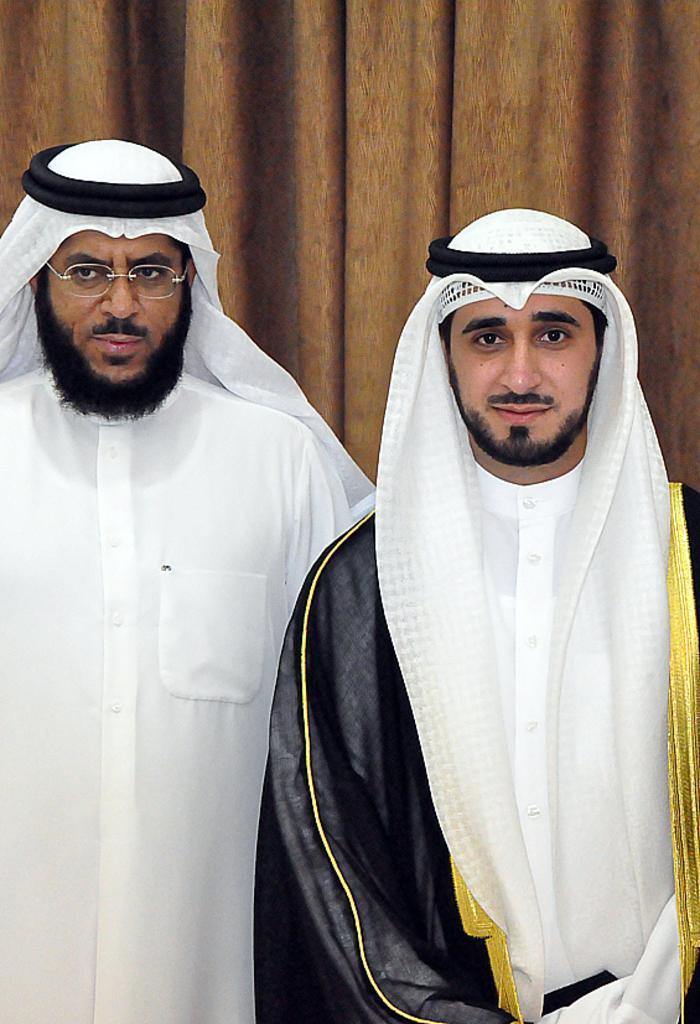Can you describe this image briefly? 2 sheikhs are standing. There are curtains at the back. 